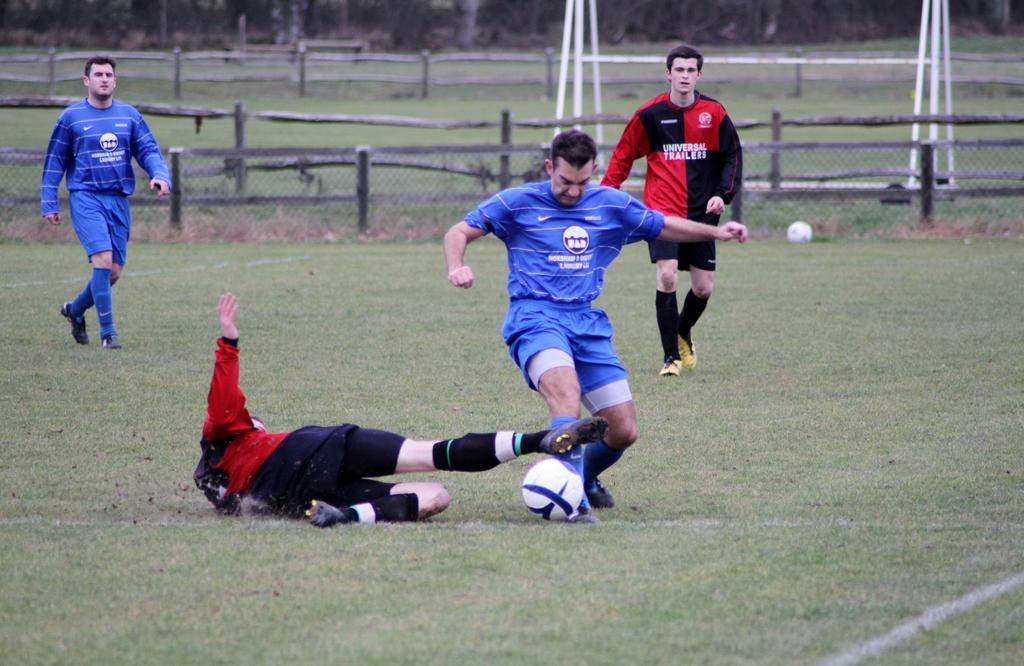How many people are in the image? There are four men in the image. What are the men doing in the image? The men are playing in a playground. What object can be seen in the image that is commonly used in sports or games? There is a ball in the image. What type of barrier is present in the image? There is a fence with branches in the image. What structure is visible in the image that might be used for catching or holding objects? There is a stand with a net in the image. What type of scarf is being used by one of the men in the image? There is no scarf present in the image; the men are playing in a playground. How does the image end, and what happens to the men after the image is taken? The image does not have an ending, and we cannot determine what happens to the men after the image is taken based on the information provided. 